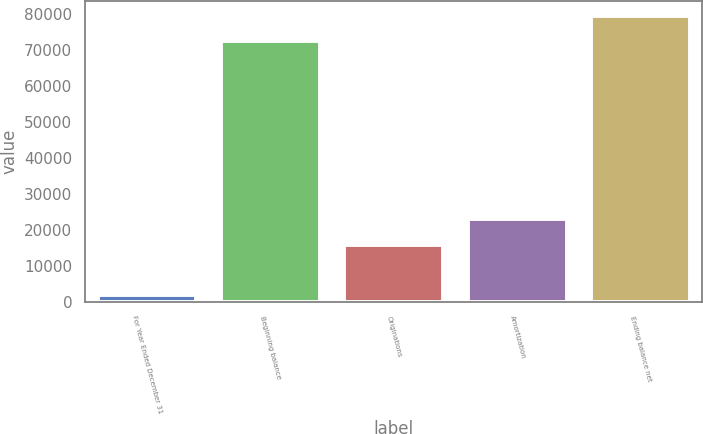<chart> <loc_0><loc_0><loc_500><loc_500><bar_chart><fcel>For Year Ended December 31<fcel>Beginning balance<fcel>Originations<fcel>Amortization<fcel>Ending balance net<nl><fcel>2014<fcel>72499<fcel>15922<fcel>23014.5<fcel>79591.5<nl></chart> 